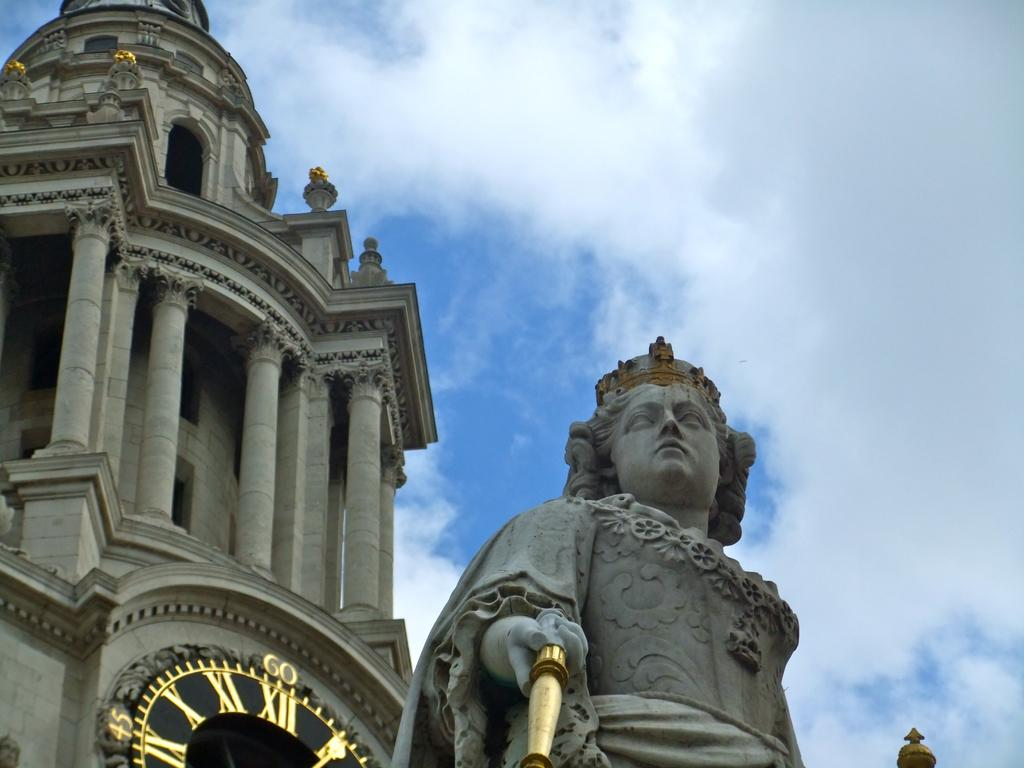What type of structure is present in the image? There is a building in the image. What other object can be seen in the image? There is a statue in the image. What can be seen in the distance in the image? The sky is visible in the background of the image. What color are the eyes of the aunt in the image? There is no aunt present in the image, so there are no eyes to describe. 